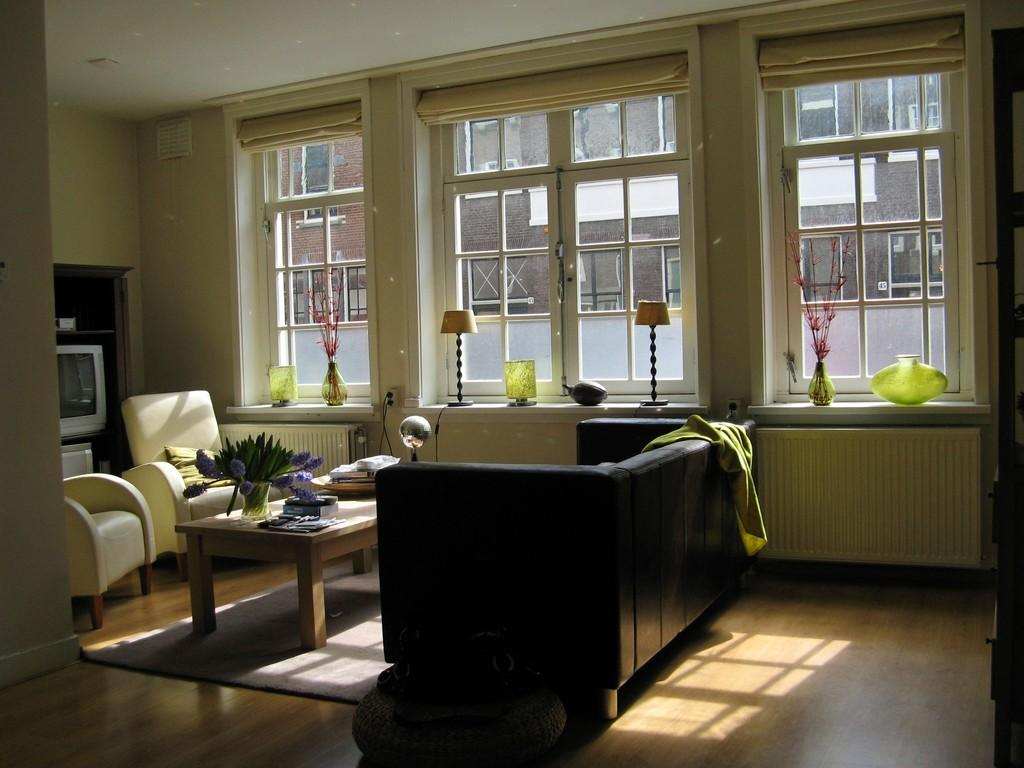What type of furniture is present in the image? There is a couch, two chairs, and a table in the image. Where are these furniture items located? The couch, chairs, and table are on the floor in the image. What is on the table? There is a plant and other objects on the table. Is there any natural element visible in the image? Yes, there is a plant on the table. What can be seen through the window in the image? There are lumps on the window. What type of animal is sitting on the couch in the image? There is no animal present on the couch in the image. Can you tell me how many rocks are on the table in the image? There are no rocks present on the table in the image. 